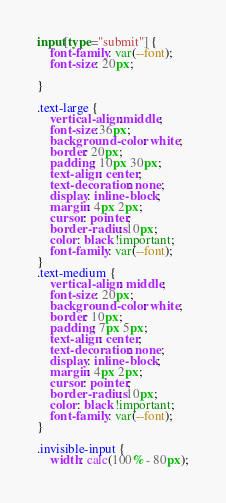<code> <loc_0><loc_0><loc_500><loc_500><_CSS_>input[type="submit"] {
    font-family: var(--font);
    font-size: 20px;

}

.text-large {
    vertical-align:middle;
    font-size:36px;
    background-color: white;
    border: 20px;
    padding: 10px 30px;
    text-align: center;
    text-decoration: none;
    display: inline-block;
    margin: 4px 2px;
    cursor: pointer;
    border-radius: 10px;
    color: black !important;
    font-family: var(--font);
}
.text-medium {
    vertical-align: middle;
    font-size: 20px;
    background-color: white;
    border: 10px;
    padding: 7px 5px;
    text-align: center;
    text-decoration: none;
    display: inline-block;
    margin: 4px 2px;
    cursor: pointer;
    border-radius: 10px;
    color: black !important;
    font-family: var(--font);
}

.invisible-input {
    width: calc(100% - 80px);</code> 